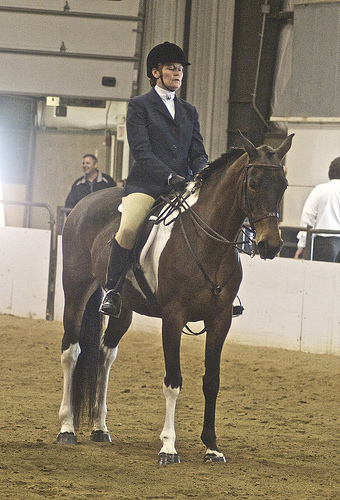<image>
Is there a man next to the wall? Yes. The man is positioned adjacent to the wall, located nearby in the same general area. Is there a jockey next to the horse? No. The jockey is not positioned next to the horse. They are located in different areas of the scene. 